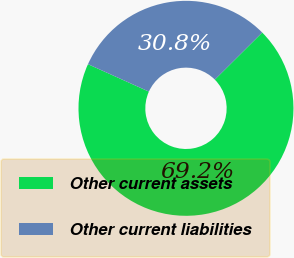<chart> <loc_0><loc_0><loc_500><loc_500><pie_chart><fcel>Other current assets<fcel>Other current liabilities<nl><fcel>69.19%<fcel>30.81%<nl></chart> 